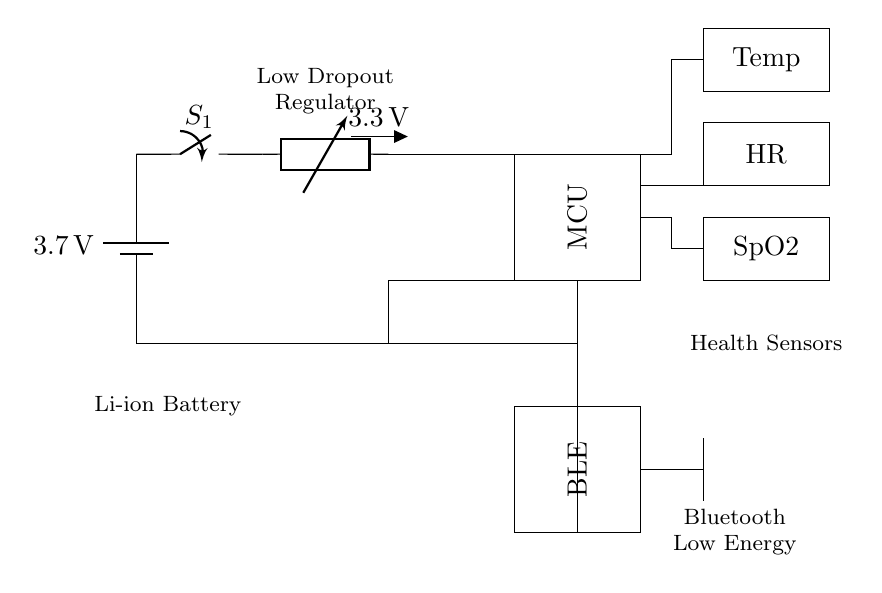What is the voltage of the battery? The circuit diagram indicates a battery labeled "3.7V", which shows the voltage supplied by the battery.
Answer: 3.7V What is the purpose of the voltage regulator? The voltage regulator in the circuit is labeled as "LDO" and outputs "3.3V", maintaining a constant output voltage to power the microcontroller and other components.
Answer: Maintain constant voltage How many health sensors are shown in the circuit diagram? The circuit includes three health sensors labeled "Temp", "HR", and "SpO2", indicating that there are three sensors in total.
Answer: Three Which component is responsible for wireless communication? The "BLE" block in the circuit diagram stands for Bluetooth Low Energy, which is specifically designed for wireless communication purposes.
Answer: BLE What is the function of the antenna in this circuit? The antenna connects to the BLE module, enabling it to transmit and receive signals wirelessly, making it essential for the communication feature of the device.
Answer: Transmit and receive signals How does the current path start in this circuit? The current path begins at the battery, starting from the positive terminal through the power switch and continuing to the voltage regulator.
Answer: From the battery What is the purpose of having a Li-ion battery in the circuit? A Li-ion battery is used for its compact size, high energy density, and ability to provide a stable voltage output, making it ideal for portable health monitoring devices.
Answer: Portable power source 